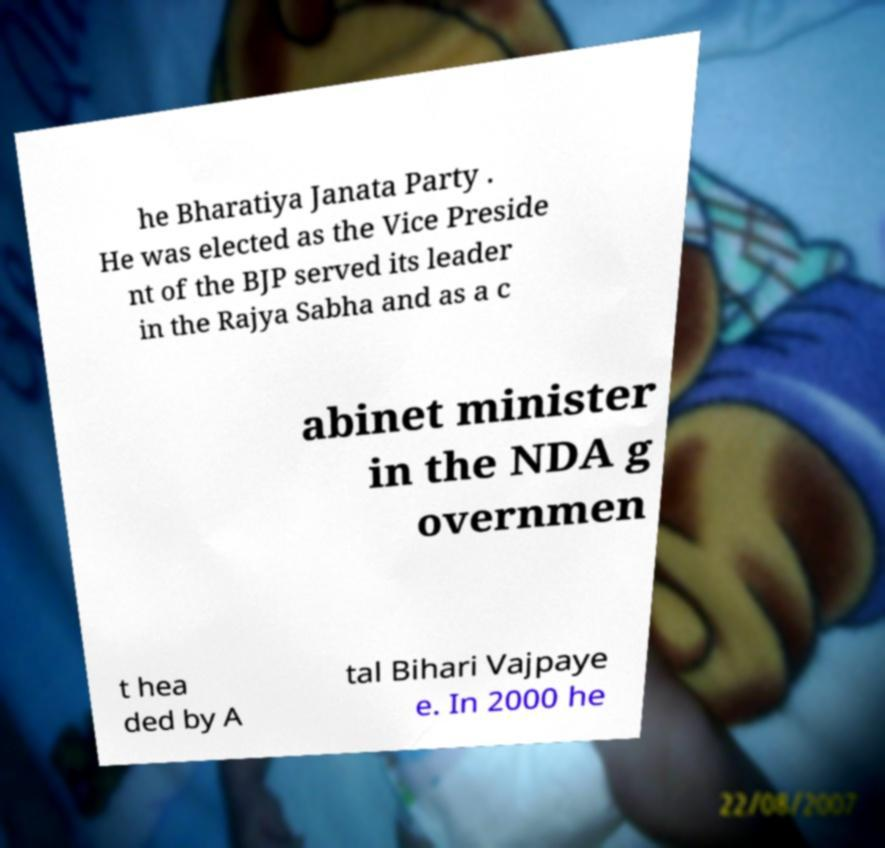What messages or text are displayed in this image? I need them in a readable, typed format. he Bharatiya Janata Party . He was elected as the Vice Preside nt of the BJP served its leader in the Rajya Sabha and as a c abinet minister in the NDA g overnmen t hea ded by A tal Bihari Vajpaye e. In 2000 he 